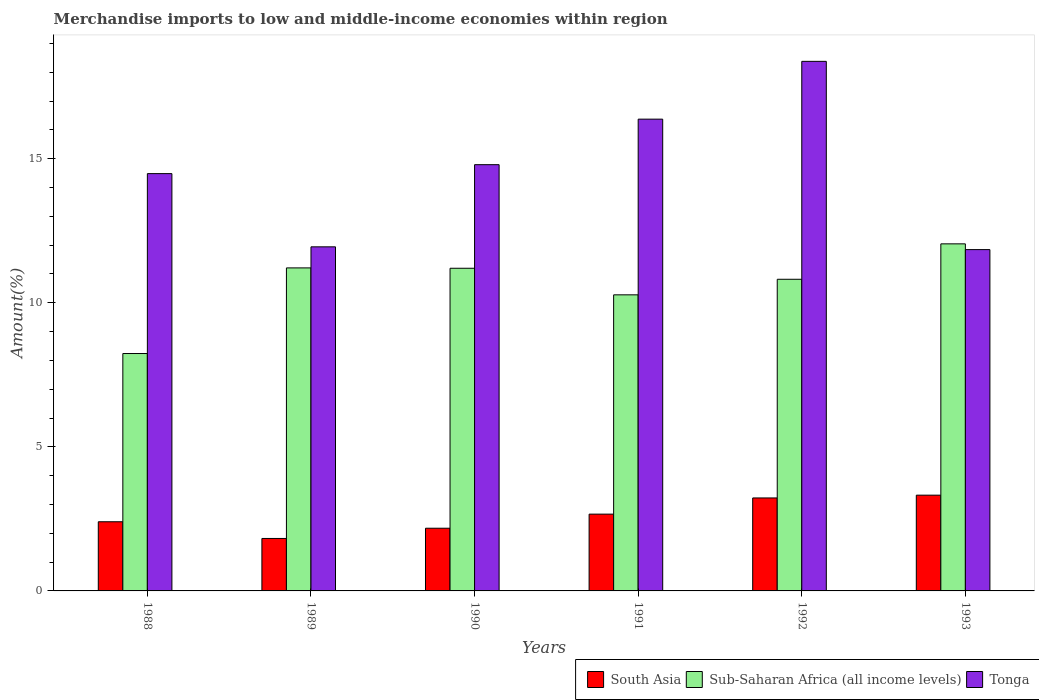How many different coloured bars are there?
Keep it short and to the point. 3. Are the number of bars per tick equal to the number of legend labels?
Your response must be concise. Yes. Are the number of bars on each tick of the X-axis equal?
Offer a very short reply. Yes. In how many cases, is the number of bars for a given year not equal to the number of legend labels?
Make the answer very short. 0. What is the percentage of amount earned from merchandise imports in South Asia in 1988?
Provide a succinct answer. 2.4. Across all years, what is the maximum percentage of amount earned from merchandise imports in South Asia?
Offer a terse response. 3.32. Across all years, what is the minimum percentage of amount earned from merchandise imports in Tonga?
Ensure brevity in your answer.  11.84. In which year was the percentage of amount earned from merchandise imports in South Asia maximum?
Provide a short and direct response. 1993. What is the total percentage of amount earned from merchandise imports in Tonga in the graph?
Your response must be concise. 87.81. What is the difference between the percentage of amount earned from merchandise imports in Tonga in 1988 and that in 1992?
Keep it short and to the point. -3.9. What is the difference between the percentage of amount earned from merchandise imports in South Asia in 1992 and the percentage of amount earned from merchandise imports in Sub-Saharan Africa (all income levels) in 1993?
Keep it short and to the point. -8.82. What is the average percentage of amount earned from merchandise imports in South Asia per year?
Keep it short and to the point. 2.6. In the year 1991, what is the difference between the percentage of amount earned from merchandise imports in Tonga and percentage of amount earned from merchandise imports in South Asia?
Make the answer very short. 13.71. What is the ratio of the percentage of amount earned from merchandise imports in South Asia in 1991 to that in 1992?
Provide a short and direct response. 0.83. Is the percentage of amount earned from merchandise imports in South Asia in 1988 less than that in 1992?
Provide a succinct answer. Yes. Is the difference between the percentage of amount earned from merchandise imports in Tonga in 1991 and 1992 greater than the difference between the percentage of amount earned from merchandise imports in South Asia in 1991 and 1992?
Ensure brevity in your answer.  No. What is the difference between the highest and the second highest percentage of amount earned from merchandise imports in Sub-Saharan Africa (all income levels)?
Ensure brevity in your answer.  0.83. What is the difference between the highest and the lowest percentage of amount earned from merchandise imports in South Asia?
Offer a terse response. 1.5. What does the 1st bar from the right in 1989 represents?
Your answer should be very brief. Tonga. Is it the case that in every year, the sum of the percentage of amount earned from merchandise imports in South Asia and percentage of amount earned from merchandise imports in Sub-Saharan Africa (all income levels) is greater than the percentage of amount earned from merchandise imports in Tonga?
Keep it short and to the point. No. How many bars are there?
Provide a succinct answer. 18. Are all the bars in the graph horizontal?
Your response must be concise. No. How many years are there in the graph?
Make the answer very short. 6. Are the values on the major ticks of Y-axis written in scientific E-notation?
Offer a very short reply. No. Does the graph contain grids?
Make the answer very short. No. How are the legend labels stacked?
Give a very brief answer. Horizontal. What is the title of the graph?
Offer a terse response. Merchandise imports to low and middle-income economies within region. Does "Ireland" appear as one of the legend labels in the graph?
Your answer should be compact. No. What is the label or title of the X-axis?
Make the answer very short. Years. What is the label or title of the Y-axis?
Offer a terse response. Amount(%). What is the Amount(%) in South Asia in 1988?
Your response must be concise. 2.4. What is the Amount(%) in Sub-Saharan Africa (all income levels) in 1988?
Provide a succinct answer. 8.24. What is the Amount(%) in Tonga in 1988?
Provide a short and direct response. 14.48. What is the Amount(%) of South Asia in 1989?
Ensure brevity in your answer.  1.82. What is the Amount(%) in Sub-Saharan Africa (all income levels) in 1989?
Ensure brevity in your answer.  11.21. What is the Amount(%) in Tonga in 1989?
Keep it short and to the point. 11.94. What is the Amount(%) in South Asia in 1990?
Provide a short and direct response. 2.18. What is the Amount(%) of Sub-Saharan Africa (all income levels) in 1990?
Keep it short and to the point. 11.2. What is the Amount(%) in Tonga in 1990?
Provide a short and direct response. 14.79. What is the Amount(%) of South Asia in 1991?
Keep it short and to the point. 2.66. What is the Amount(%) of Sub-Saharan Africa (all income levels) in 1991?
Ensure brevity in your answer.  10.28. What is the Amount(%) in Tonga in 1991?
Ensure brevity in your answer.  16.37. What is the Amount(%) of South Asia in 1992?
Give a very brief answer. 3.23. What is the Amount(%) in Sub-Saharan Africa (all income levels) in 1992?
Offer a terse response. 10.82. What is the Amount(%) of Tonga in 1992?
Your answer should be compact. 18.38. What is the Amount(%) in South Asia in 1993?
Offer a terse response. 3.32. What is the Amount(%) in Sub-Saharan Africa (all income levels) in 1993?
Offer a very short reply. 12.04. What is the Amount(%) in Tonga in 1993?
Give a very brief answer. 11.84. Across all years, what is the maximum Amount(%) of South Asia?
Offer a terse response. 3.32. Across all years, what is the maximum Amount(%) of Sub-Saharan Africa (all income levels)?
Your response must be concise. 12.04. Across all years, what is the maximum Amount(%) of Tonga?
Provide a short and direct response. 18.38. Across all years, what is the minimum Amount(%) in South Asia?
Your response must be concise. 1.82. Across all years, what is the minimum Amount(%) of Sub-Saharan Africa (all income levels)?
Keep it short and to the point. 8.24. Across all years, what is the minimum Amount(%) in Tonga?
Provide a succinct answer. 11.84. What is the total Amount(%) in South Asia in the graph?
Your response must be concise. 15.61. What is the total Amount(%) in Sub-Saharan Africa (all income levels) in the graph?
Ensure brevity in your answer.  63.78. What is the total Amount(%) of Tonga in the graph?
Keep it short and to the point. 87.81. What is the difference between the Amount(%) of South Asia in 1988 and that in 1989?
Keep it short and to the point. 0.58. What is the difference between the Amount(%) in Sub-Saharan Africa (all income levels) in 1988 and that in 1989?
Provide a short and direct response. -2.97. What is the difference between the Amount(%) of Tonga in 1988 and that in 1989?
Give a very brief answer. 2.54. What is the difference between the Amount(%) in South Asia in 1988 and that in 1990?
Provide a short and direct response. 0.22. What is the difference between the Amount(%) of Sub-Saharan Africa (all income levels) in 1988 and that in 1990?
Keep it short and to the point. -2.96. What is the difference between the Amount(%) in Tonga in 1988 and that in 1990?
Offer a very short reply. -0.31. What is the difference between the Amount(%) in South Asia in 1988 and that in 1991?
Provide a short and direct response. -0.26. What is the difference between the Amount(%) in Sub-Saharan Africa (all income levels) in 1988 and that in 1991?
Your response must be concise. -2.04. What is the difference between the Amount(%) in Tonga in 1988 and that in 1991?
Make the answer very short. -1.89. What is the difference between the Amount(%) of South Asia in 1988 and that in 1992?
Provide a short and direct response. -0.83. What is the difference between the Amount(%) of Sub-Saharan Africa (all income levels) in 1988 and that in 1992?
Offer a very short reply. -2.58. What is the difference between the Amount(%) in Tonga in 1988 and that in 1992?
Provide a succinct answer. -3.9. What is the difference between the Amount(%) of South Asia in 1988 and that in 1993?
Ensure brevity in your answer.  -0.92. What is the difference between the Amount(%) of Sub-Saharan Africa (all income levels) in 1988 and that in 1993?
Your answer should be compact. -3.81. What is the difference between the Amount(%) in Tonga in 1988 and that in 1993?
Your response must be concise. 2.64. What is the difference between the Amount(%) of South Asia in 1989 and that in 1990?
Provide a short and direct response. -0.36. What is the difference between the Amount(%) of Sub-Saharan Africa (all income levels) in 1989 and that in 1990?
Offer a terse response. 0.01. What is the difference between the Amount(%) in Tonga in 1989 and that in 1990?
Your answer should be very brief. -2.85. What is the difference between the Amount(%) of South Asia in 1989 and that in 1991?
Ensure brevity in your answer.  -0.84. What is the difference between the Amount(%) in Sub-Saharan Africa (all income levels) in 1989 and that in 1991?
Your response must be concise. 0.93. What is the difference between the Amount(%) in Tonga in 1989 and that in 1991?
Your response must be concise. -4.43. What is the difference between the Amount(%) in South Asia in 1989 and that in 1992?
Make the answer very short. -1.41. What is the difference between the Amount(%) in Sub-Saharan Africa (all income levels) in 1989 and that in 1992?
Provide a short and direct response. 0.39. What is the difference between the Amount(%) of Tonga in 1989 and that in 1992?
Provide a short and direct response. -6.44. What is the difference between the Amount(%) of South Asia in 1989 and that in 1993?
Give a very brief answer. -1.5. What is the difference between the Amount(%) of Sub-Saharan Africa (all income levels) in 1989 and that in 1993?
Make the answer very short. -0.83. What is the difference between the Amount(%) in Tonga in 1989 and that in 1993?
Your answer should be compact. 0.1. What is the difference between the Amount(%) of South Asia in 1990 and that in 1991?
Your answer should be compact. -0.49. What is the difference between the Amount(%) of Sub-Saharan Africa (all income levels) in 1990 and that in 1991?
Offer a very short reply. 0.92. What is the difference between the Amount(%) in Tonga in 1990 and that in 1991?
Your answer should be compact. -1.58. What is the difference between the Amount(%) in South Asia in 1990 and that in 1992?
Give a very brief answer. -1.05. What is the difference between the Amount(%) in Sub-Saharan Africa (all income levels) in 1990 and that in 1992?
Your answer should be compact. 0.38. What is the difference between the Amount(%) in Tonga in 1990 and that in 1992?
Your answer should be compact. -3.59. What is the difference between the Amount(%) in South Asia in 1990 and that in 1993?
Keep it short and to the point. -1.15. What is the difference between the Amount(%) of Sub-Saharan Africa (all income levels) in 1990 and that in 1993?
Offer a terse response. -0.85. What is the difference between the Amount(%) in Tonga in 1990 and that in 1993?
Your answer should be compact. 2.95. What is the difference between the Amount(%) of South Asia in 1991 and that in 1992?
Give a very brief answer. -0.56. What is the difference between the Amount(%) of Sub-Saharan Africa (all income levels) in 1991 and that in 1992?
Provide a short and direct response. -0.54. What is the difference between the Amount(%) in Tonga in 1991 and that in 1992?
Ensure brevity in your answer.  -2.01. What is the difference between the Amount(%) of South Asia in 1991 and that in 1993?
Give a very brief answer. -0.66. What is the difference between the Amount(%) of Sub-Saharan Africa (all income levels) in 1991 and that in 1993?
Your answer should be compact. -1.77. What is the difference between the Amount(%) of Tonga in 1991 and that in 1993?
Give a very brief answer. 4.53. What is the difference between the Amount(%) in South Asia in 1992 and that in 1993?
Your response must be concise. -0.1. What is the difference between the Amount(%) in Sub-Saharan Africa (all income levels) in 1992 and that in 1993?
Give a very brief answer. -1.23. What is the difference between the Amount(%) in Tonga in 1992 and that in 1993?
Ensure brevity in your answer.  6.53. What is the difference between the Amount(%) in South Asia in 1988 and the Amount(%) in Sub-Saharan Africa (all income levels) in 1989?
Give a very brief answer. -8.81. What is the difference between the Amount(%) in South Asia in 1988 and the Amount(%) in Tonga in 1989?
Give a very brief answer. -9.54. What is the difference between the Amount(%) of Sub-Saharan Africa (all income levels) in 1988 and the Amount(%) of Tonga in 1989?
Give a very brief answer. -3.7. What is the difference between the Amount(%) in South Asia in 1988 and the Amount(%) in Sub-Saharan Africa (all income levels) in 1990?
Your answer should be compact. -8.8. What is the difference between the Amount(%) in South Asia in 1988 and the Amount(%) in Tonga in 1990?
Your answer should be compact. -12.39. What is the difference between the Amount(%) in Sub-Saharan Africa (all income levels) in 1988 and the Amount(%) in Tonga in 1990?
Your answer should be compact. -6.55. What is the difference between the Amount(%) of South Asia in 1988 and the Amount(%) of Sub-Saharan Africa (all income levels) in 1991?
Provide a succinct answer. -7.88. What is the difference between the Amount(%) of South Asia in 1988 and the Amount(%) of Tonga in 1991?
Provide a succinct answer. -13.97. What is the difference between the Amount(%) in Sub-Saharan Africa (all income levels) in 1988 and the Amount(%) in Tonga in 1991?
Ensure brevity in your answer.  -8.13. What is the difference between the Amount(%) of South Asia in 1988 and the Amount(%) of Sub-Saharan Africa (all income levels) in 1992?
Offer a very short reply. -8.42. What is the difference between the Amount(%) of South Asia in 1988 and the Amount(%) of Tonga in 1992?
Your answer should be very brief. -15.98. What is the difference between the Amount(%) of Sub-Saharan Africa (all income levels) in 1988 and the Amount(%) of Tonga in 1992?
Offer a very short reply. -10.14. What is the difference between the Amount(%) in South Asia in 1988 and the Amount(%) in Sub-Saharan Africa (all income levels) in 1993?
Offer a terse response. -9.64. What is the difference between the Amount(%) in South Asia in 1988 and the Amount(%) in Tonga in 1993?
Provide a short and direct response. -9.44. What is the difference between the Amount(%) in Sub-Saharan Africa (all income levels) in 1988 and the Amount(%) in Tonga in 1993?
Offer a very short reply. -3.61. What is the difference between the Amount(%) of South Asia in 1989 and the Amount(%) of Sub-Saharan Africa (all income levels) in 1990?
Provide a short and direct response. -9.38. What is the difference between the Amount(%) of South Asia in 1989 and the Amount(%) of Tonga in 1990?
Offer a very short reply. -12.97. What is the difference between the Amount(%) in Sub-Saharan Africa (all income levels) in 1989 and the Amount(%) in Tonga in 1990?
Offer a terse response. -3.58. What is the difference between the Amount(%) in South Asia in 1989 and the Amount(%) in Sub-Saharan Africa (all income levels) in 1991?
Offer a terse response. -8.45. What is the difference between the Amount(%) of South Asia in 1989 and the Amount(%) of Tonga in 1991?
Provide a short and direct response. -14.55. What is the difference between the Amount(%) of Sub-Saharan Africa (all income levels) in 1989 and the Amount(%) of Tonga in 1991?
Give a very brief answer. -5.16. What is the difference between the Amount(%) in South Asia in 1989 and the Amount(%) in Sub-Saharan Africa (all income levels) in 1992?
Offer a terse response. -8.99. What is the difference between the Amount(%) of South Asia in 1989 and the Amount(%) of Tonga in 1992?
Offer a very short reply. -16.56. What is the difference between the Amount(%) of Sub-Saharan Africa (all income levels) in 1989 and the Amount(%) of Tonga in 1992?
Your response must be concise. -7.17. What is the difference between the Amount(%) in South Asia in 1989 and the Amount(%) in Sub-Saharan Africa (all income levels) in 1993?
Your answer should be compact. -10.22. What is the difference between the Amount(%) in South Asia in 1989 and the Amount(%) in Tonga in 1993?
Give a very brief answer. -10.02. What is the difference between the Amount(%) of Sub-Saharan Africa (all income levels) in 1989 and the Amount(%) of Tonga in 1993?
Ensure brevity in your answer.  -0.63. What is the difference between the Amount(%) of South Asia in 1990 and the Amount(%) of Sub-Saharan Africa (all income levels) in 1991?
Your answer should be very brief. -8.1. What is the difference between the Amount(%) of South Asia in 1990 and the Amount(%) of Tonga in 1991?
Keep it short and to the point. -14.2. What is the difference between the Amount(%) of Sub-Saharan Africa (all income levels) in 1990 and the Amount(%) of Tonga in 1991?
Your response must be concise. -5.17. What is the difference between the Amount(%) of South Asia in 1990 and the Amount(%) of Sub-Saharan Africa (all income levels) in 1992?
Make the answer very short. -8.64. What is the difference between the Amount(%) of South Asia in 1990 and the Amount(%) of Tonga in 1992?
Offer a very short reply. -16.2. What is the difference between the Amount(%) of Sub-Saharan Africa (all income levels) in 1990 and the Amount(%) of Tonga in 1992?
Provide a short and direct response. -7.18. What is the difference between the Amount(%) of South Asia in 1990 and the Amount(%) of Sub-Saharan Africa (all income levels) in 1993?
Provide a short and direct response. -9.87. What is the difference between the Amount(%) of South Asia in 1990 and the Amount(%) of Tonga in 1993?
Your answer should be compact. -9.67. What is the difference between the Amount(%) in Sub-Saharan Africa (all income levels) in 1990 and the Amount(%) in Tonga in 1993?
Ensure brevity in your answer.  -0.65. What is the difference between the Amount(%) of South Asia in 1991 and the Amount(%) of Sub-Saharan Africa (all income levels) in 1992?
Keep it short and to the point. -8.15. What is the difference between the Amount(%) of South Asia in 1991 and the Amount(%) of Tonga in 1992?
Give a very brief answer. -15.71. What is the difference between the Amount(%) in Sub-Saharan Africa (all income levels) in 1991 and the Amount(%) in Tonga in 1992?
Your answer should be compact. -8.1. What is the difference between the Amount(%) in South Asia in 1991 and the Amount(%) in Sub-Saharan Africa (all income levels) in 1993?
Provide a succinct answer. -9.38. What is the difference between the Amount(%) of South Asia in 1991 and the Amount(%) of Tonga in 1993?
Make the answer very short. -9.18. What is the difference between the Amount(%) of Sub-Saharan Africa (all income levels) in 1991 and the Amount(%) of Tonga in 1993?
Your response must be concise. -1.57. What is the difference between the Amount(%) of South Asia in 1992 and the Amount(%) of Sub-Saharan Africa (all income levels) in 1993?
Provide a short and direct response. -8.82. What is the difference between the Amount(%) of South Asia in 1992 and the Amount(%) of Tonga in 1993?
Your answer should be compact. -8.62. What is the difference between the Amount(%) in Sub-Saharan Africa (all income levels) in 1992 and the Amount(%) in Tonga in 1993?
Give a very brief answer. -1.03. What is the average Amount(%) of South Asia per year?
Your answer should be very brief. 2.6. What is the average Amount(%) in Sub-Saharan Africa (all income levels) per year?
Your response must be concise. 10.63. What is the average Amount(%) in Tonga per year?
Keep it short and to the point. 14.63. In the year 1988, what is the difference between the Amount(%) of South Asia and Amount(%) of Sub-Saharan Africa (all income levels)?
Ensure brevity in your answer.  -5.84. In the year 1988, what is the difference between the Amount(%) of South Asia and Amount(%) of Tonga?
Make the answer very short. -12.08. In the year 1988, what is the difference between the Amount(%) of Sub-Saharan Africa (all income levels) and Amount(%) of Tonga?
Your answer should be very brief. -6.24. In the year 1989, what is the difference between the Amount(%) of South Asia and Amount(%) of Sub-Saharan Africa (all income levels)?
Your answer should be very brief. -9.39. In the year 1989, what is the difference between the Amount(%) of South Asia and Amount(%) of Tonga?
Offer a terse response. -10.12. In the year 1989, what is the difference between the Amount(%) in Sub-Saharan Africa (all income levels) and Amount(%) in Tonga?
Keep it short and to the point. -0.73. In the year 1990, what is the difference between the Amount(%) of South Asia and Amount(%) of Sub-Saharan Africa (all income levels)?
Offer a terse response. -9.02. In the year 1990, what is the difference between the Amount(%) in South Asia and Amount(%) in Tonga?
Make the answer very short. -12.62. In the year 1990, what is the difference between the Amount(%) of Sub-Saharan Africa (all income levels) and Amount(%) of Tonga?
Ensure brevity in your answer.  -3.59. In the year 1991, what is the difference between the Amount(%) of South Asia and Amount(%) of Sub-Saharan Africa (all income levels)?
Keep it short and to the point. -7.61. In the year 1991, what is the difference between the Amount(%) in South Asia and Amount(%) in Tonga?
Your answer should be very brief. -13.71. In the year 1991, what is the difference between the Amount(%) in Sub-Saharan Africa (all income levels) and Amount(%) in Tonga?
Your response must be concise. -6.1. In the year 1992, what is the difference between the Amount(%) of South Asia and Amount(%) of Sub-Saharan Africa (all income levels)?
Provide a short and direct response. -7.59. In the year 1992, what is the difference between the Amount(%) in South Asia and Amount(%) in Tonga?
Your response must be concise. -15.15. In the year 1992, what is the difference between the Amount(%) in Sub-Saharan Africa (all income levels) and Amount(%) in Tonga?
Your response must be concise. -7.56. In the year 1993, what is the difference between the Amount(%) in South Asia and Amount(%) in Sub-Saharan Africa (all income levels)?
Make the answer very short. -8.72. In the year 1993, what is the difference between the Amount(%) in South Asia and Amount(%) in Tonga?
Provide a succinct answer. -8.52. In the year 1993, what is the difference between the Amount(%) of Sub-Saharan Africa (all income levels) and Amount(%) of Tonga?
Provide a short and direct response. 0.2. What is the ratio of the Amount(%) in South Asia in 1988 to that in 1989?
Offer a terse response. 1.32. What is the ratio of the Amount(%) of Sub-Saharan Africa (all income levels) in 1988 to that in 1989?
Ensure brevity in your answer.  0.73. What is the ratio of the Amount(%) of Tonga in 1988 to that in 1989?
Provide a succinct answer. 1.21. What is the ratio of the Amount(%) in South Asia in 1988 to that in 1990?
Provide a short and direct response. 1.1. What is the ratio of the Amount(%) of Sub-Saharan Africa (all income levels) in 1988 to that in 1990?
Offer a very short reply. 0.74. What is the ratio of the Amount(%) of Tonga in 1988 to that in 1990?
Offer a very short reply. 0.98. What is the ratio of the Amount(%) of South Asia in 1988 to that in 1991?
Offer a terse response. 0.9. What is the ratio of the Amount(%) in Sub-Saharan Africa (all income levels) in 1988 to that in 1991?
Your answer should be very brief. 0.8. What is the ratio of the Amount(%) in Tonga in 1988 to that in 1991?
Your answer should be very brief. 0.88. What is the ratio of the Amount(%) of South Asia in 1988 to that in 1992?
Keep it short and to the point. 0.74. What is the ratio of the Amount(%) in Sub-Saharan Africa (all income levels) in 1988 to that in 1992?
Ensure brevity in your answer.  0.76. What is the ratio of the Amount(%) of Tonga in 1988 to that in 1992?
Your response must be concise. 0.79. What is the ratio of the Amount(%) in South Asia in 1988 to that in 1993?
Provide a succinct answer. 0.72. What is the ratio of the Amount(%) of Sub-Saharan Africa (all income levels) in 1988 to that in 1993?
Your answer should be compact. 0.68. What is the ratio of the Amount(%) in Tonga in 1988 to that in 1993?
Your answer should be very brief. 1.22. What is the ratio of the Amount(%) of South Asia in 1989 to that in 1990?
Provide a short and direct response. 0.84. What is the ratio of the Amount(%) in Sub-Saharan Africa (all income levels) in 1989 to that in 1990?
Make the answer very short. 1. What is the ratio of the Amount(%) in Tonga in 1989 to that in 1990?
Give a very brief answer. 0.81. What is the ratio of the Amount(%) in South Asia in 1989 to that in 1991?
Offer a very short reply. 0.68. What is the ratio of the Amount(%) in Sub-Saharan Africa (all income levels) in 1989 to that in 1991?
Your response must be concise. 1.09. What is the ratio of the Amount(%) in Tonga in 1989 to that in 1991?
Offer a very short reply. 0.73. What is the ratio of the Amount(%) in South Asia in 1989 to that in 1992?
Your response must be concise. 0.56. What is the ratio of the Amount(%) of Sub-Saharan Africa (all income levels) in 1989 to that in 1992?
Make the answer very short. 1.04. What is the ratio of the Amount(%) in Tonga in 1989 to that in 1992?
Your answer should be very brief. 0.65. What is the ratio of the Amount(%) of South Asia in 1989 to that in 1993?
Make the answer very short. 0.55. What is the ratio of the Amount(%) of Sub-Saharan Africa (all income levels) in 1989 to that in 1993?
Provide a short and direct response. 0.93. What is the ratio of the Amount(%) of South Asia in 1990 to that in 1991?
Ensure brevity in your answer.  0.82. What is the ratio of the Amount(%) in Sub-Saharan Africa (all income levels) in 1990 to that in 1991?
Your answer should be compact. 1.09. What is the ratio of the Amount(%) in Tonga in 1990 to that in 1991?
Provide a short and direct response. 0.9. What is the ratio of the Amount(%) in South Asia in 1990 to that in 1992?
Your answer should be compact. 0.67. What is the ratio of the Amount(%) of Sub-Saharan Africa (all income levels) in 1990 to that in 1992?
Offer a very short reply. 1.04. What is the ratio of the Amount(%) in Tonga in 1990 to that in 1992?
Give a very brief answer. 0.8. What is the ratio of the Amount(%) in South Asia in 1990 to that in 1993?
Provide a succinct answer. 0.65. What is the ratio of the Amount(%) in Sub-Saharan Africa (all income levels) in 1990 to that in 1993?
Provide a short and direct response. 0.93. What is the ratio of the Amount(%) of Tonga in 1990 to that in 1993?
Your answer should be very brief. 1.25. What is the ratio of the Amount(%) in South Asia in 1991 to that in 1992?
Your response must be concise. 0.83. What is the ratio of the Amount(%) in Sub-Saharan Africa (all income levels) in 1991 to that in 1992?
Your answer should be very brief. 0.95. What is the ratio of the Amount(%) of Tonga in 1991 to that in 1992?
Keep it short and to the point. 0.89. What is the ratio of the Amount(%) of South Asia in 1991 to that in 1993?
Keep it short and to the point. 0.8. What is the ratio of the Amount(%) of Sub-Saharan Africa (all income levels) in 1991 to that in 1993?
Offer a very short reply. 0.85. What is the ratio of the Amount(%) in Tonga in 1991 to that in 1993?
Keep it short and to the point. 1.38. What is the ratio of the Amount(%) in Sub-Saharan Africa (all income levels) in 1992 to that in 1993?
Your response must be concise. 0.9. What is the ratio of the Amount(%) in Tonga in 1992 to that in 1993?
Give a very brief answer. 1.55. What is the difference between the highest and the second highest Amount(%) in South Asia?
Your answer should be compact. 0.1. What is the difference between the highest and the second highest Amount(%) of Sub-Saharan Africa (all income levels)?
Provide a short and direct response. 0.83. What is the difference between the highest and the second highest Amount(%) in Tonga?
Keep it short and to the point. 2.01. What is the difference between the highest and the lowest Amount(%) in South Asia?
Offer a very short reply. 1.5. What is the difference between the highest and the lowest Amount(%) in Sub-Saharan Africa (all income levels)?
Provide a succinct answer. 3.81. What is the difference between the highest and the lowest Amount(%) in Tonga?
Make the answer very short. 6.53. 